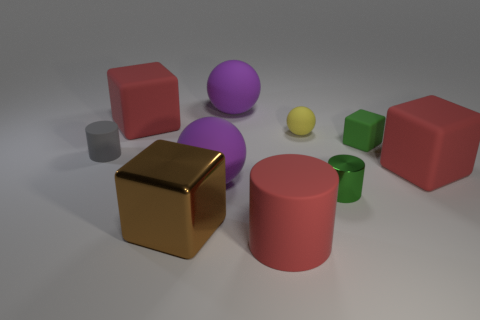Subtract all balls. How many objects are left? 7 Subtract 0 blue cylinders. How many objects are left? 10 Subtract all big rubber cylinders. Subtract all small spheres. How many objects are left? 8 Add 5 cylinders. How many cylinders are left? 8 Add 4 matte spheres. How many matte spheres exist? 7 